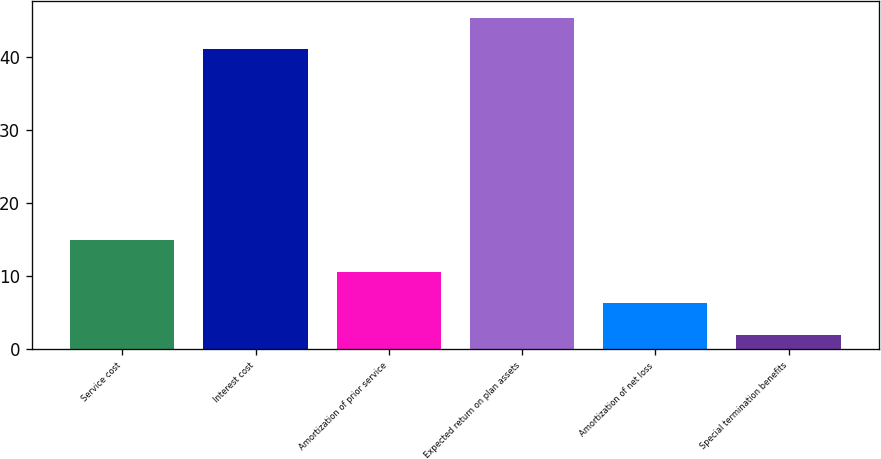Convert chart to OTSL. <chart><loc_0><loc_0><loc_500><loc_500><bar_chart><fcel>Service cost<fcel>Interest cost<fcel>Amortization of prior service<fcel>Expected return on plan assets<fcel>Amortization of net loss<fcel>Special termination benefits<nl><fcel>14.9<fcel>41<fcel>10.6<fcel>45.3<fcel>6.3<fcel>2<nl></chart> 